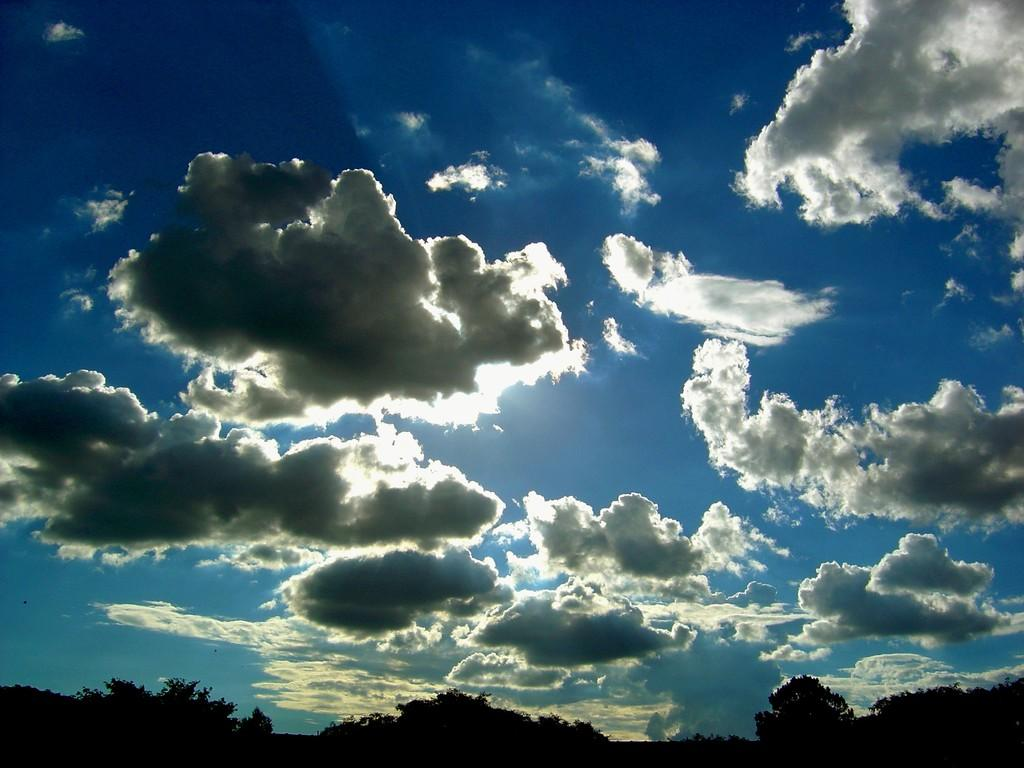Where was the picture taken? The picture was clicked outside. What can be seen in the foreground of the image? There are trees in the foreground of the image. What is visible in the background of the image? The sky is visible in the background of the image. What is the condition of the sky in the image? The sky is full of clouds. What type of soap is being used to create the clouds in the image? There is no soap present in the image, and the clouds are natural formations in the sky. Can you see people playing in the image? There is no indication of people playing in the image; it primarily features trees and a cloudy sky. 